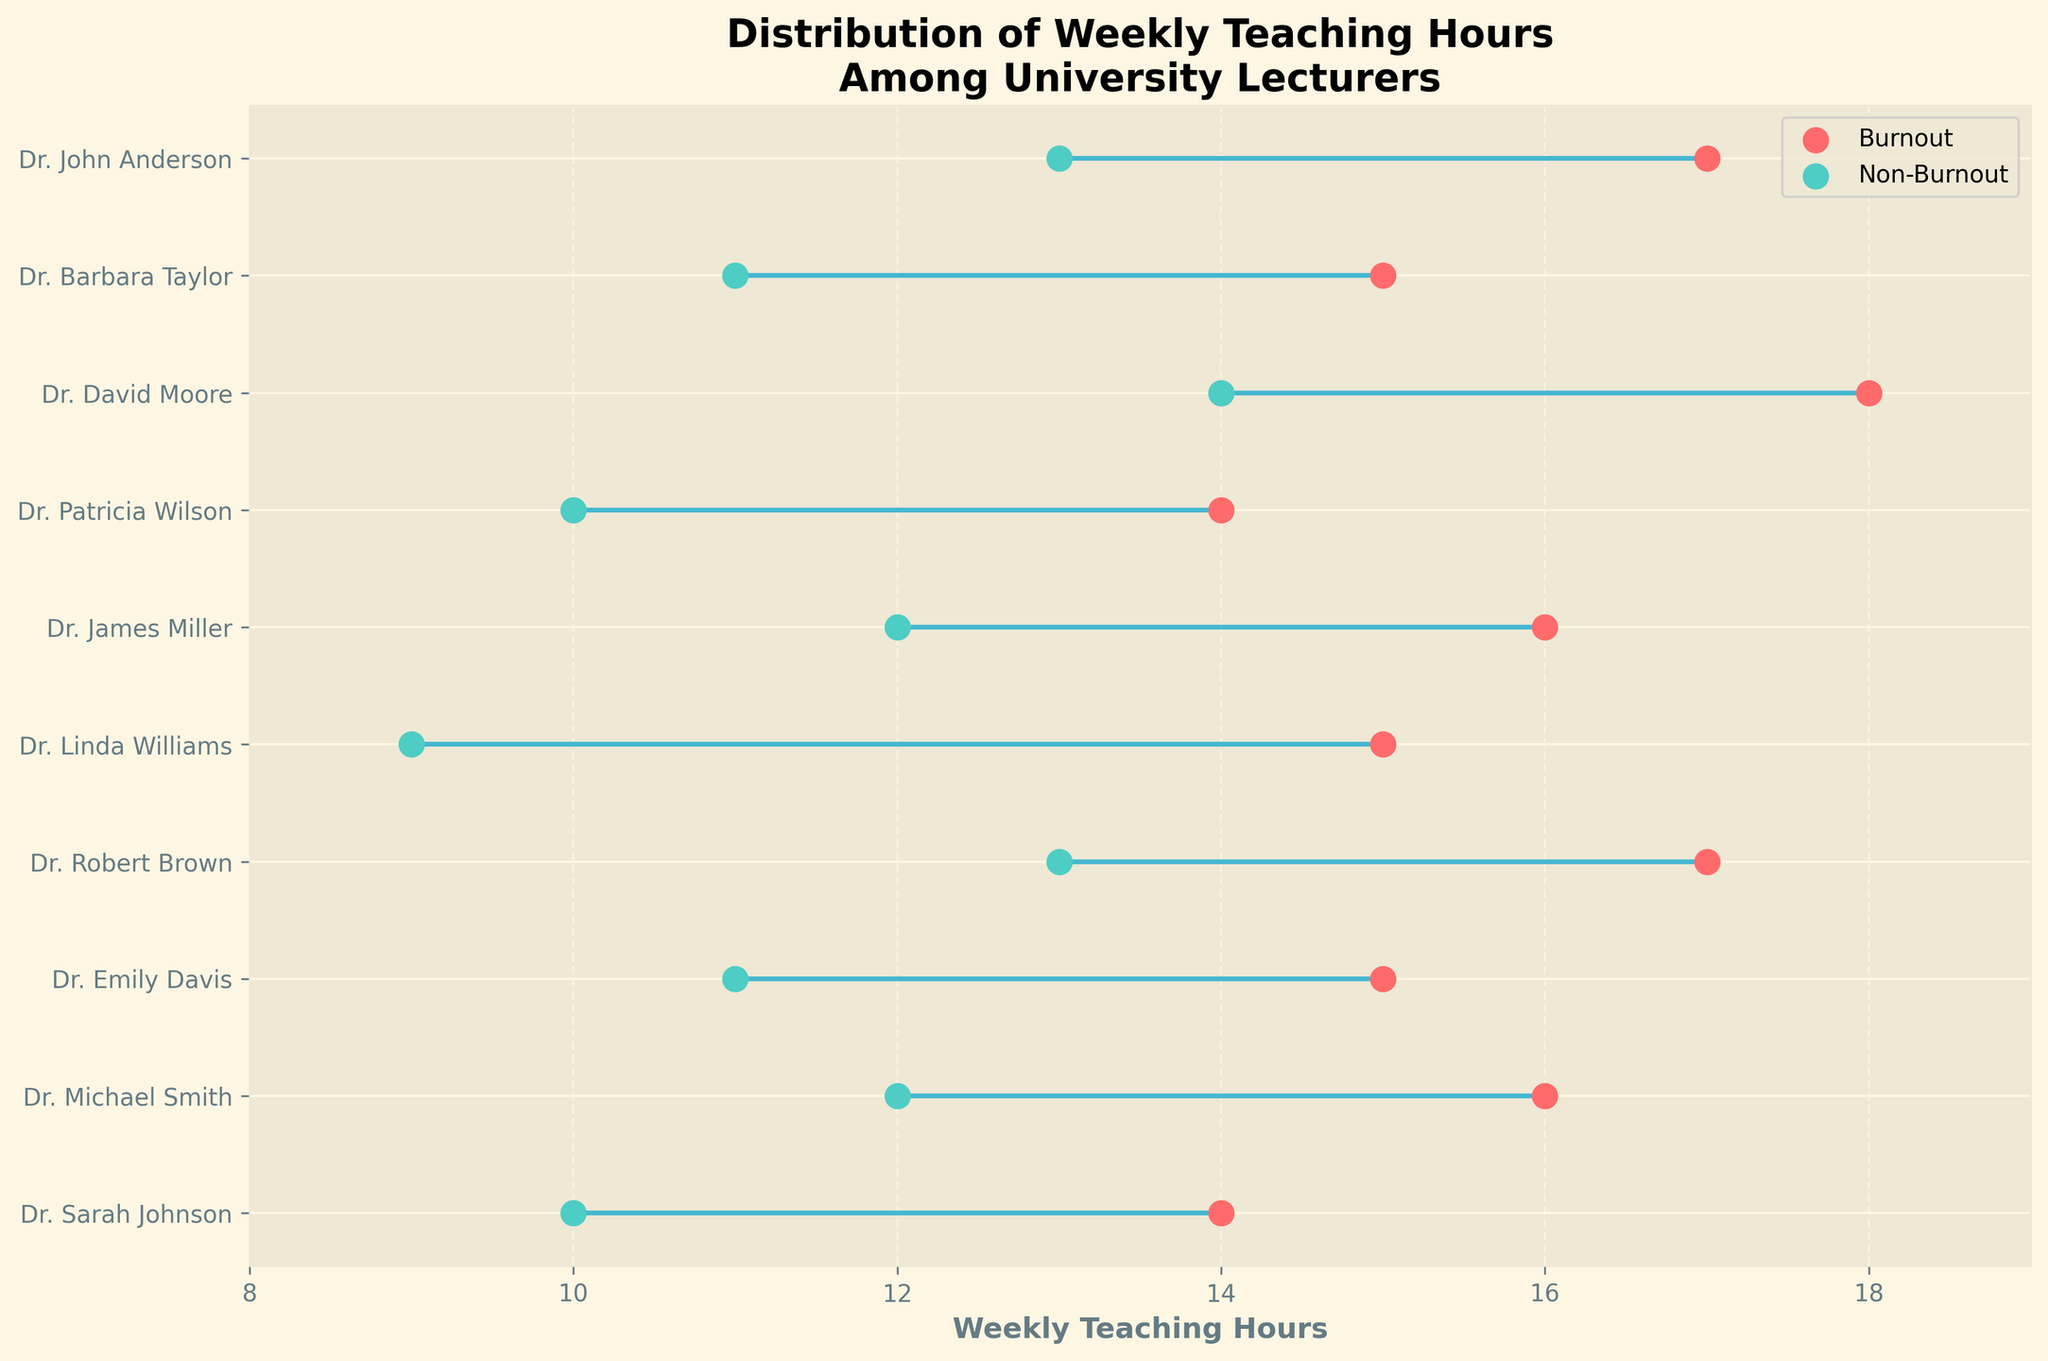How many lecturers are shown in the plot? The plot has y-ticks labeling each unique lecturer. Counting the unique lecturers gives the total number of lecturers shown.
Answer: 9 What is the weekly teaching hour range for lecturers in burnout status? The burnout hours for each lecturer are shown by one set of dots; finding the minimum and maximum values among these dots indicates the range. The minimum is 14 and the maximum is 18.
Answer: 14 to 18 Which lecturer has the largest difference in weekly teaching hours between burnout and non-burnout status? Observing the lines connecting each pair of dots, the largest difference has the longest line. Dr. Linda Williams has 15 hours (burnout) and 9 hours (non-burnout), making a difference of 6 hours.
Answer: Dr. Linda Williams Who teaches the fewest hours per week in non-burnout status? The dots labeled for non-burnout hours show Dr. Linda Williams with the lowest teaching hours, which is 9.
Answer: Dr. Linda Williams What is the average weekly teaching hours for lecturers in burnout status? Adding the burnout hours for all lecturers and dividing by the number of lecturers: (14 + 16 + 15 + 17 + 15 + 16 + 14 + 18 + 15 + 17) / 9 = 147 / 9 = 16.33.
Answer: 16.33 How does the average weekly teaching hours compare between burnout and non-burnout statuses? Calculate the average for both statuses and compare: Burnout average is 16.33 (see prior calculation). Non-burnout average is (10 + 12 + 11 + 13 + 9 + 12 + 10 + 14 + 11 + 13) / 9 = 105 / 9 = 11.67. Burnout average is higher.
Answer: Burnout is higher Is there any lecturer whose teaching hours remain constant regardless of burnout status? By checking if any lecturer has equal dots for both statuses, all lecturers show differences in hours.
Answer: No What is the median value of weekly teaching hours for non-burnout lecturers? List non-burnout hours and find the median in the ordered list: 9, 10, 10, 11, 11, 12, 12, 13, 13, 14. The median value (middle value in an ordered list) is 12.
Answer: 12 